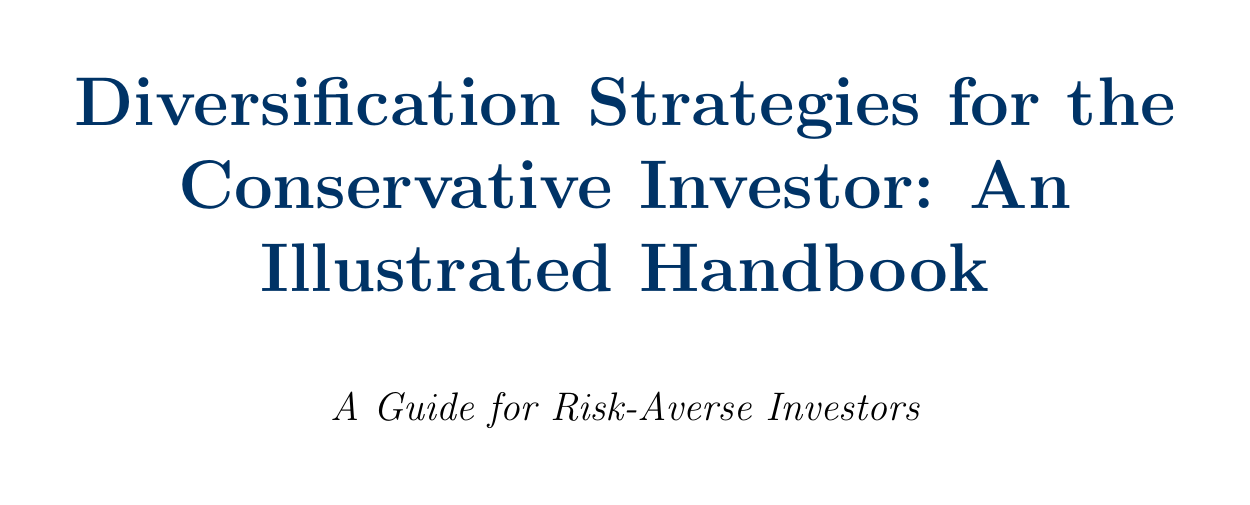What is the title of the handbook? The title is stated in the opening section of the document.
Answer: Diversification Strategies for the Conservative Investor: An Illustrated Handbook What percentage of stocks is recommended in the 60/40 Portfolio? The allocation model specifies the ratio of stocks to bonds.
Answer: 60% What is the example used in the section on Psychological Barriers to Aggressive Investing? The document provides a case study as an example to illustrate key concepts.
Answer: Case study: Overcoming fear after the 2008 financial crisis What strategy involves staggering bond maturities? The technique is introduced in the appropriate section of the document.
Answer: Building a Bond Ladder What is the resource suggested for fund research? The handbook includes a section on further learning with specific sources listed.
Answer: Morningstar.com for fund research How long did the backtested results of the Permanent Portfolio cover? The time period for backtested results is mentioned in its section.
Answer: 1972-2022 What rebalancing technique adjusts allocations on a fixed schedule? The document discusses multiple rebalancing techniques with specific titles.
Answer: Calendar Rebalancing Which asset class is emphasized for conservative investors? The basics section lists types of investments that suit conservative profiles.
Answer: Bonds 